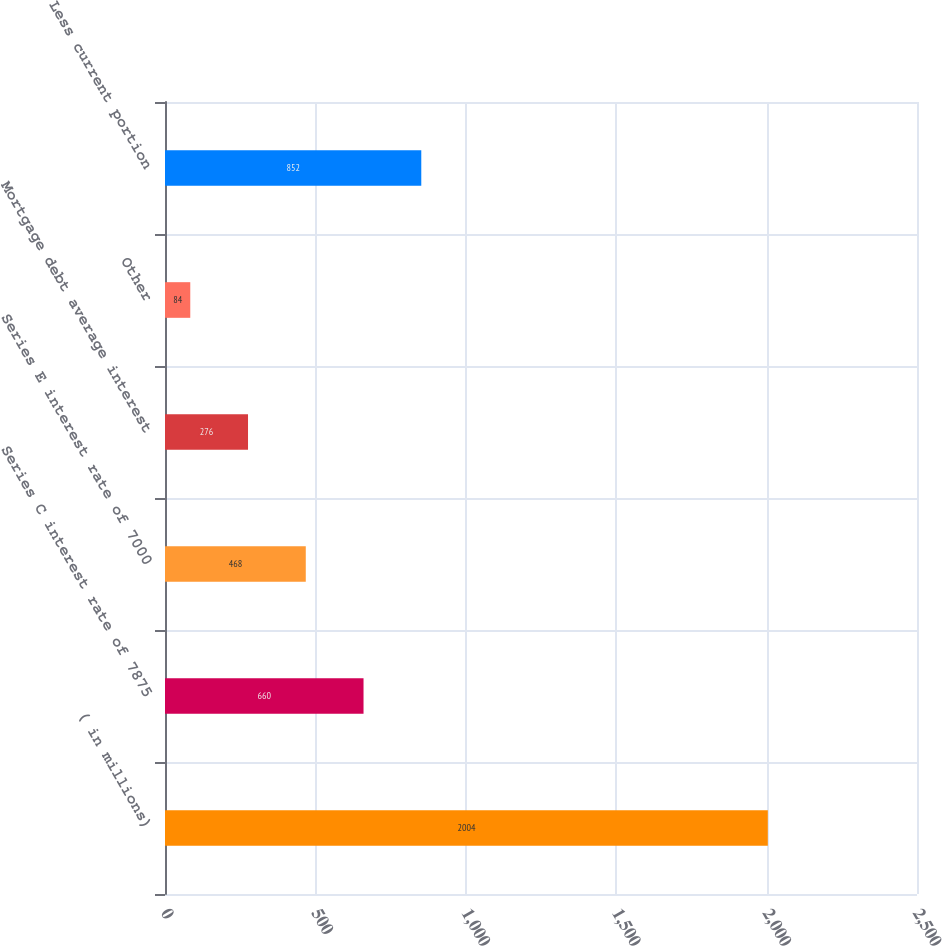Convert chart to OTSL. <chart><loc_0><loc_0><loc_500><loc_500><bar_chart><fcel>( in millions)<fcel>Series C interest rate of 7875<fcel>Series E interest rate of 7000<fcel>Mortgage debt average interest<fcel>Other<fcel>Less current portion<nl><fcel>2004<fcel>660<fcel>468<fcel>276<fcel>84<fcel>852<nl></chart> 